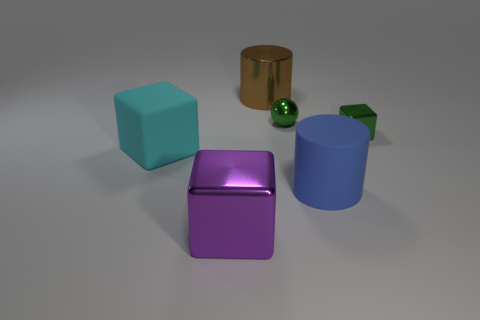Add 2 metal balls. How many objects exist? 8 Subtract all balls. How many objects are left? 5 Subtract 1 green spheres. How many objects are left? 5 Subtract all yellow matte objects. Subtract all big blue rubber objects. How many objects are left? 5 Add 1 large cylinders. How many large cylinders are left? 3 Add 2 green shiny things. How many green shiny things exist? 4 